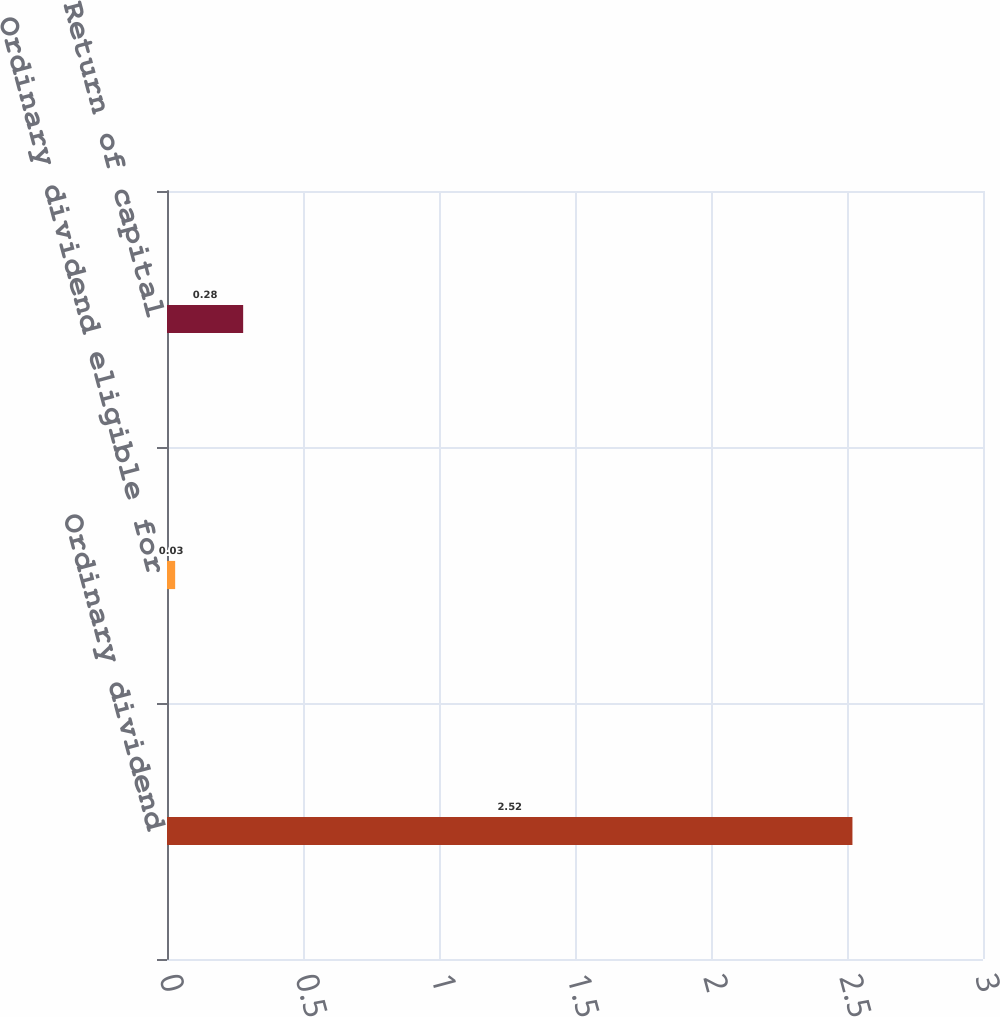<chart> <loc_0><loc_0><loc_500><loc_500><bar_chart><fcel>Ordinary dividend<fcel>Ordinary dividend eligible for<fcel>Return of capital<nl><fcel>2.52<fcel>0.03<fcel>0.28<nl></chart> 